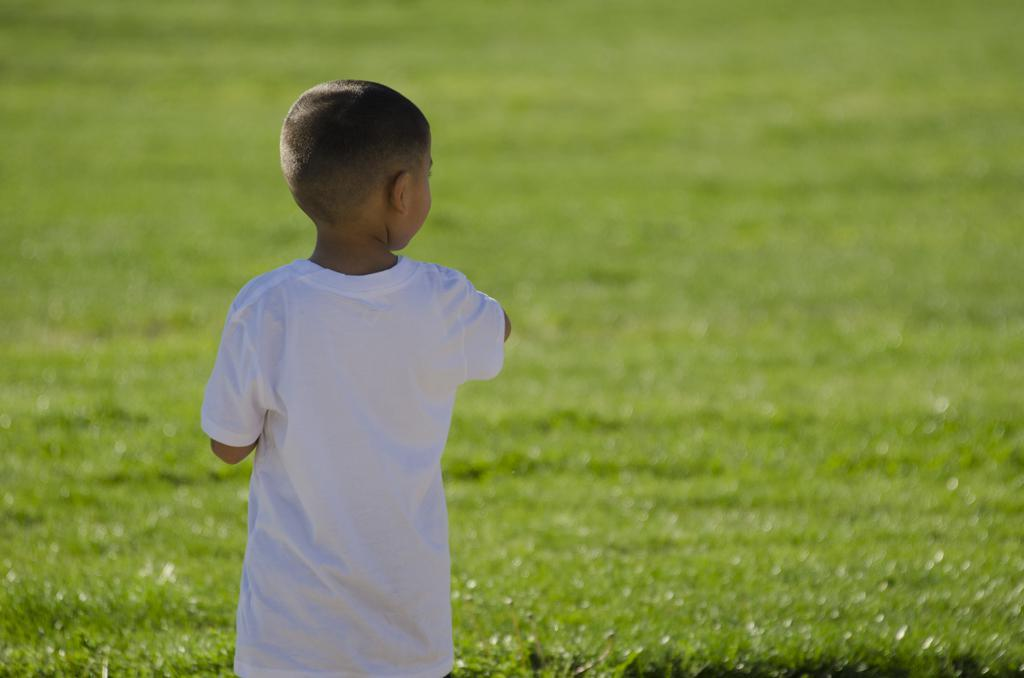What is the main subject of the image? The main subject of the image is a boy. Can you describe the boy's position in the image? The boy is standing on the surface of the grass. What type of suit is the boy wearing in the image? There is no suit visible in the image; the boy is not wearing any clothing mentioned in the provided facts. Is there any smoke coming from the boy in the image? There is no smoke present in the image. Are there any stockings visible on the boy in the image? There is no mention of stockings or any other clothing items besides the boy standing on the grass. 